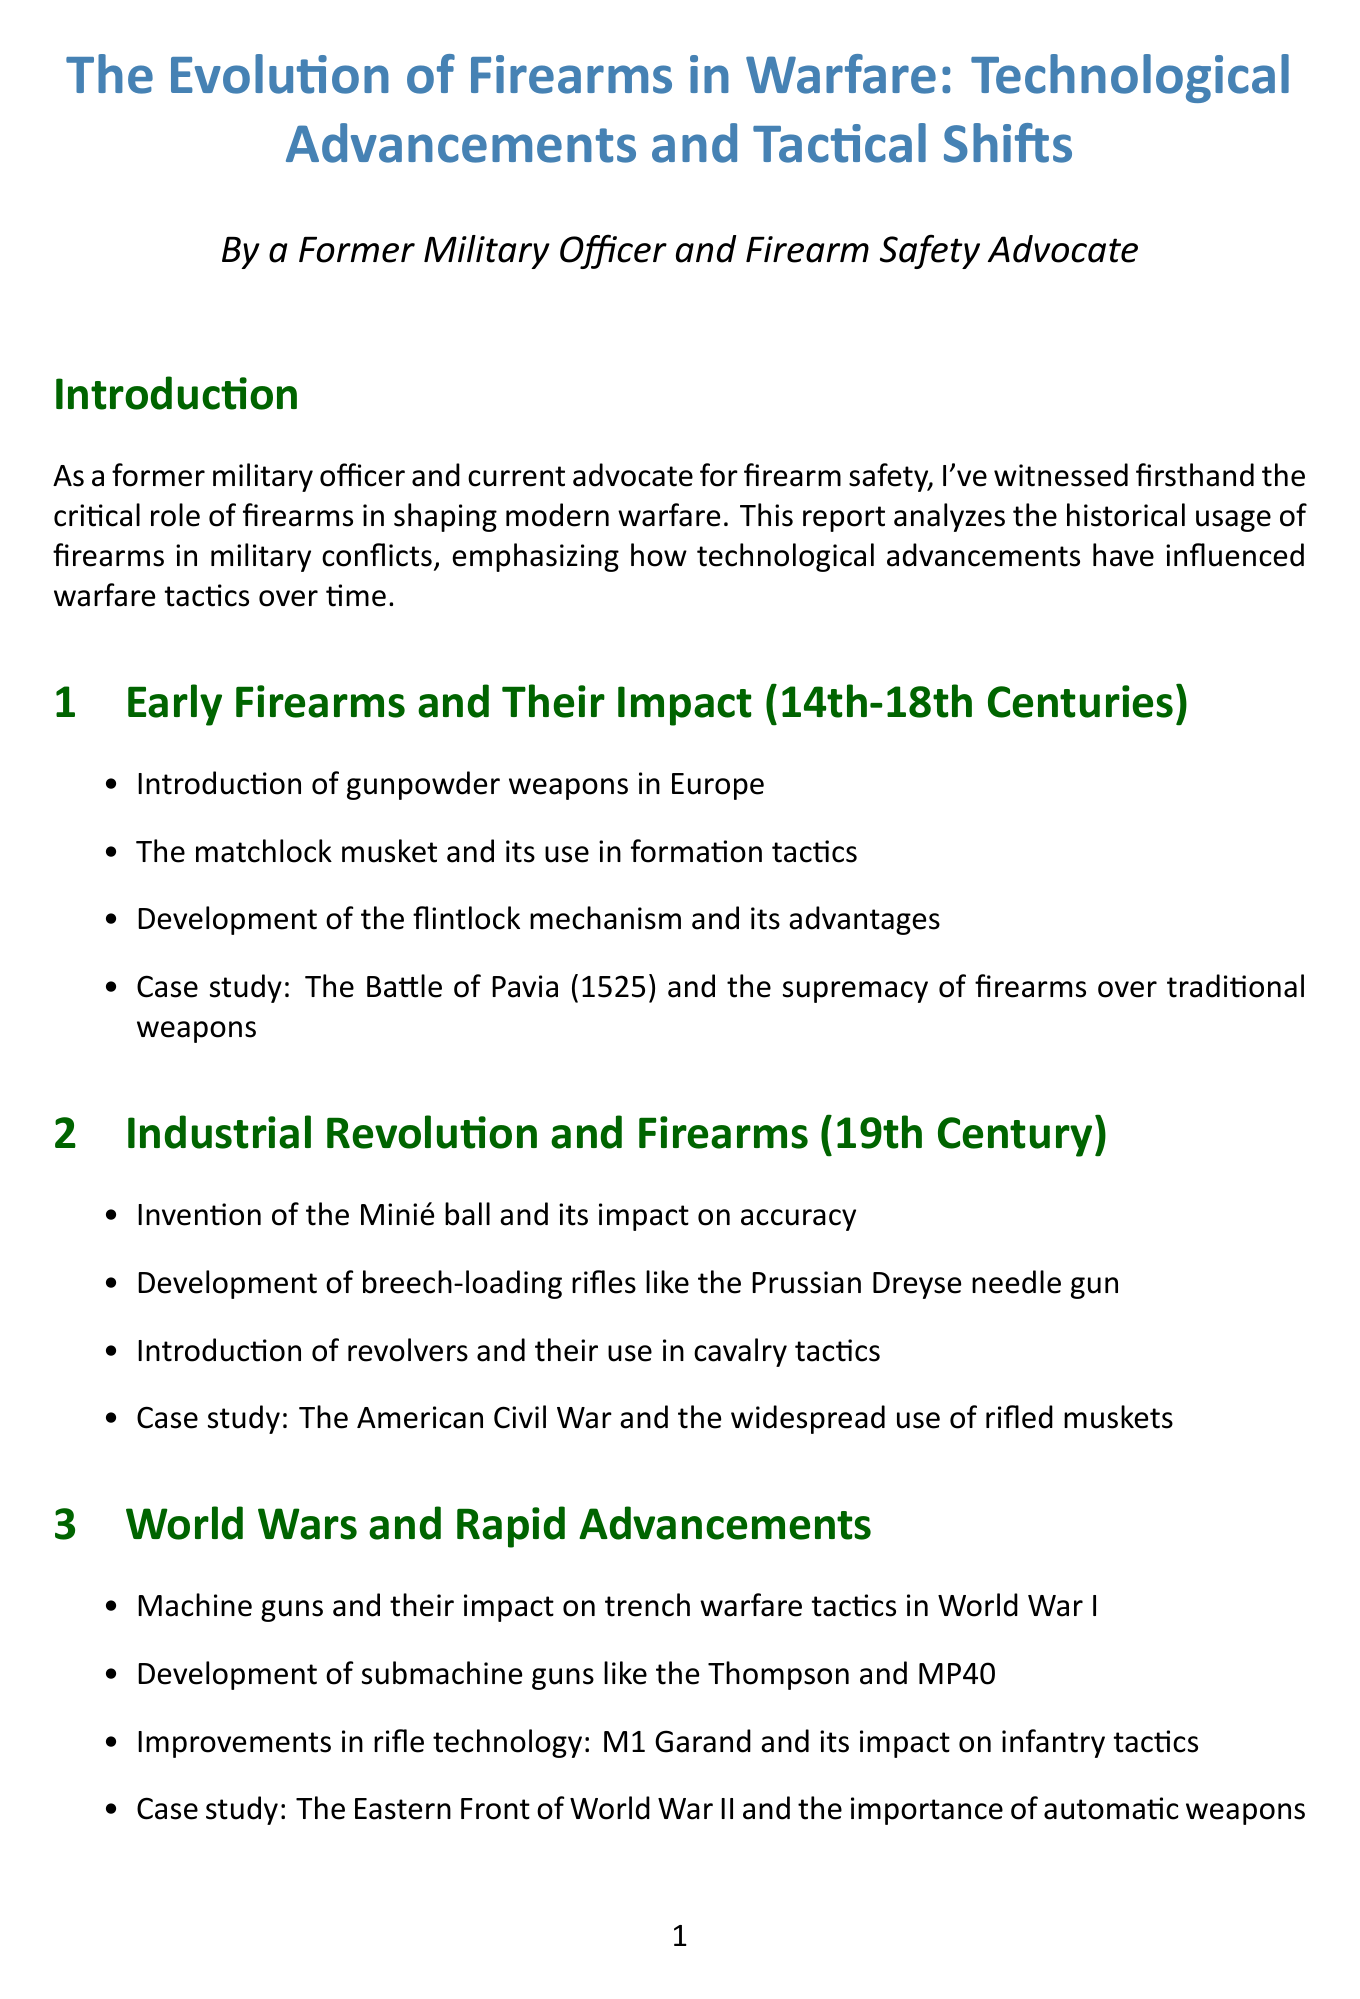What is the title of the report? The title of the report is provided at the beginning of the document.
Answer: The Evolution of Firearms in Warfare: Technological Advancements and Tactical Shifts Which century is associated with early firearms according to the report? The report states the time frame for early firearms in the section title.
Answer: 14th-18th Centuries What innovation in firearms is highlighted during the 19th century? The document discusses specific innovations and their impacts in the 19th-century section.
Answer: Minié ball Name a case study mentioned in the World Wars section. The case studies are specifically mentioned under each section in the report.
Answer: The Eastern Front of World War II What firearm design is introduced in the modern era? The report describes specific developments in firearms design during the modern era.
Answer: Assault rifles How does the report categorize future trends in firearms technology? The report includes a dedicated section on future trends, listing several technological implications.
Answer: Smart gun technology What is one key ethical consideration mentioned in the future trends? The ethical considerations are mentioned as part of the future trends discussion.
Answer: The role of AI What does the personal insights section discuss about firearms safety? The section highlights personal experiences related to firearms safety in different contexts.
Answer: Proper firearms safety practices According to the report, what psychological aspect does the military experience relate to firearms advancements? The document includes a personal insight on psychological impacts due to advancements in firearms.
Answer: Psychological well-being 